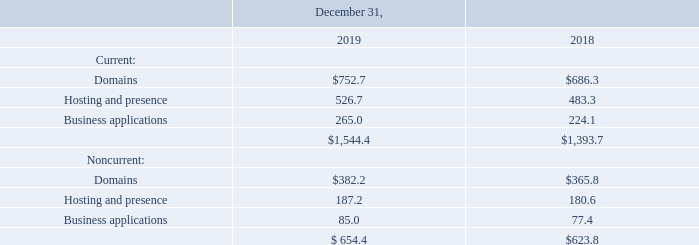8. Deferred Revenue
Deferred revenue consisted of the following:
What are the 3 types of non-current deferred revenue? Domains, hosting and presence, business applications. What is the 2019 year end total non-current deferred revenue? 654.4. What is the 2018 year end total non-current deferred revenue? 623.8. What is the average total current deferred revenue for 2018 and 2019? (1,544.4+1,393.7)/2
Answer: 1469.05. What is the average total non-current deferred revenue for 2018 and 2019? (654.4+623.8)/2
Answer: 639.1. Was total current or total non-current deferred revenue greater for 2019 year end? 1,544.4>654.4
Answer: current. 